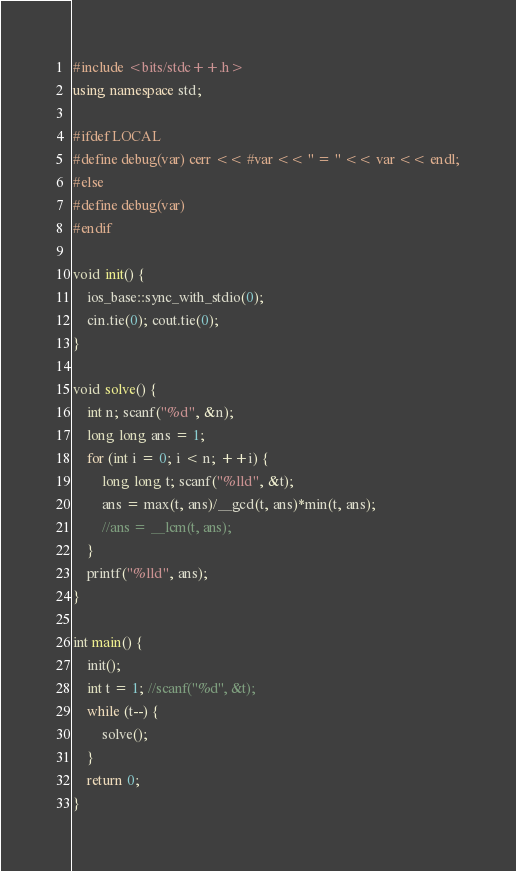<code> <loc_0><loc_0><loc_500><loc_500><_C++_>#include <bits/stdc++.h>
using namespace std;

#ifdef LOCAL
#define debug(var) cerr << #var << " = " << var << endl;
#else
#define debug(var)
#endif

void init() {
	ios_base::sync_with_stdio(0);
	cin.tie(0); cout.tie(0);
}

void solve() {
	int n; scanf("%d", &n);
	long long ans = 1;
	for (int i = 0; i < n; ++i) {
		long long t; scanf("%lld", &t);
		ans = max(t, ans)/__gcd(t, ans)*min(t, ans);
		//ans = __lcm(t, ans);
	}
	printf("%lld", ans);
}

int main() {
	init();
	int t = 1; //scanf("%d", &t);
	while (t--) {
		solve();
	}
	return 0;
}
</code> 